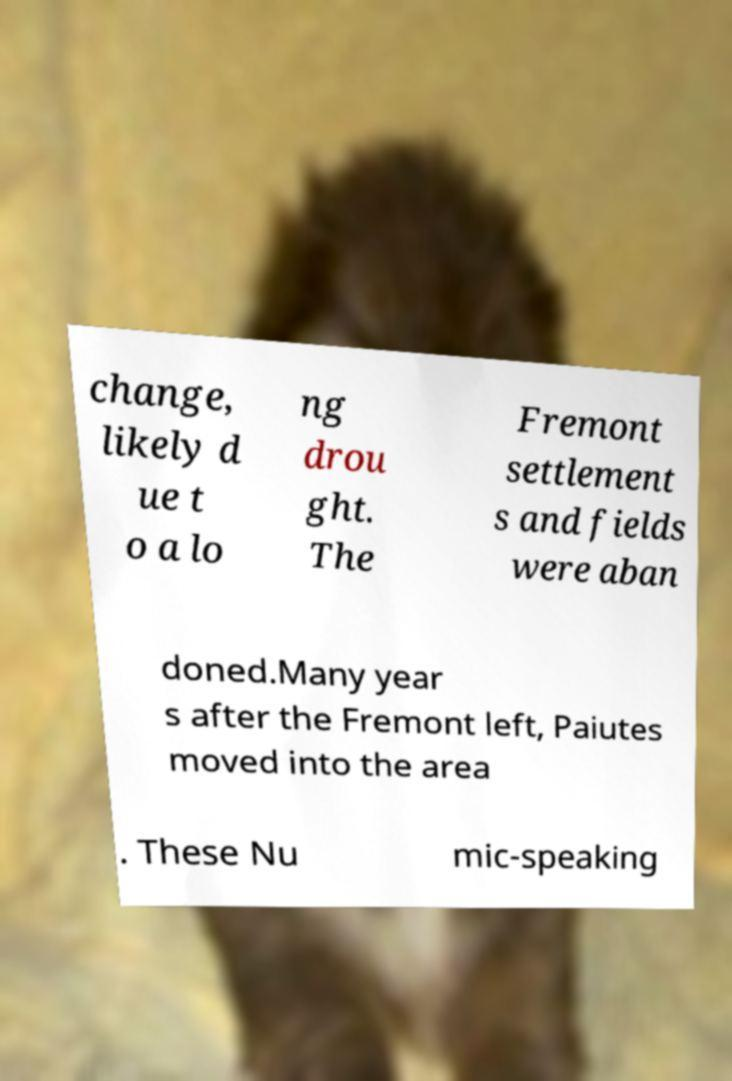Could you extract and type out the text from this image? change, likely d ue t o a lo ng drou ght. The Fremont settlement s and fields were aban doned.Many year s after the Fremont left, Paiutes moved into the area . These Nu mic-speaking 